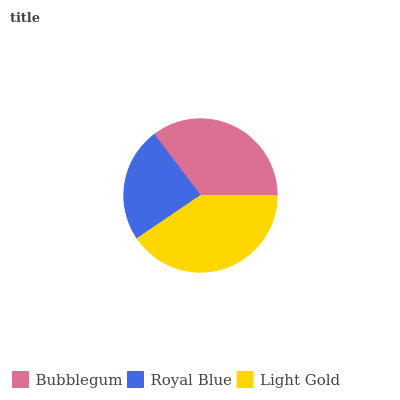Is Royal Blue the minimum?
Answer yes or no. Yes. Is Light Gold the maximum?
Answer yes or no. Yes. Is Light Gold the minimum?
Answer yes or no. No. Is Royal Blue the maximum?
Answer yes or no. No. Is Light Gold greater than Royal Blue?
Answer yes or no. Yes. Is Royal Blue less than Light Gold?
Answer yes or no. Yes. Is Royal Blue greater than Light Gold?
Answer yes or no. No. Is Light Gold less than Royal Blue?
Answer yes or no. No. Is Bubblegum the high median?
Answer yes or no. Yes. Is Bubblegum the low median?
Answer yes or no. Yes. Is Royal Blue the high median?
Answer yes or no. No. Is Royal Blue the low median?
Answer yes or no. No. 